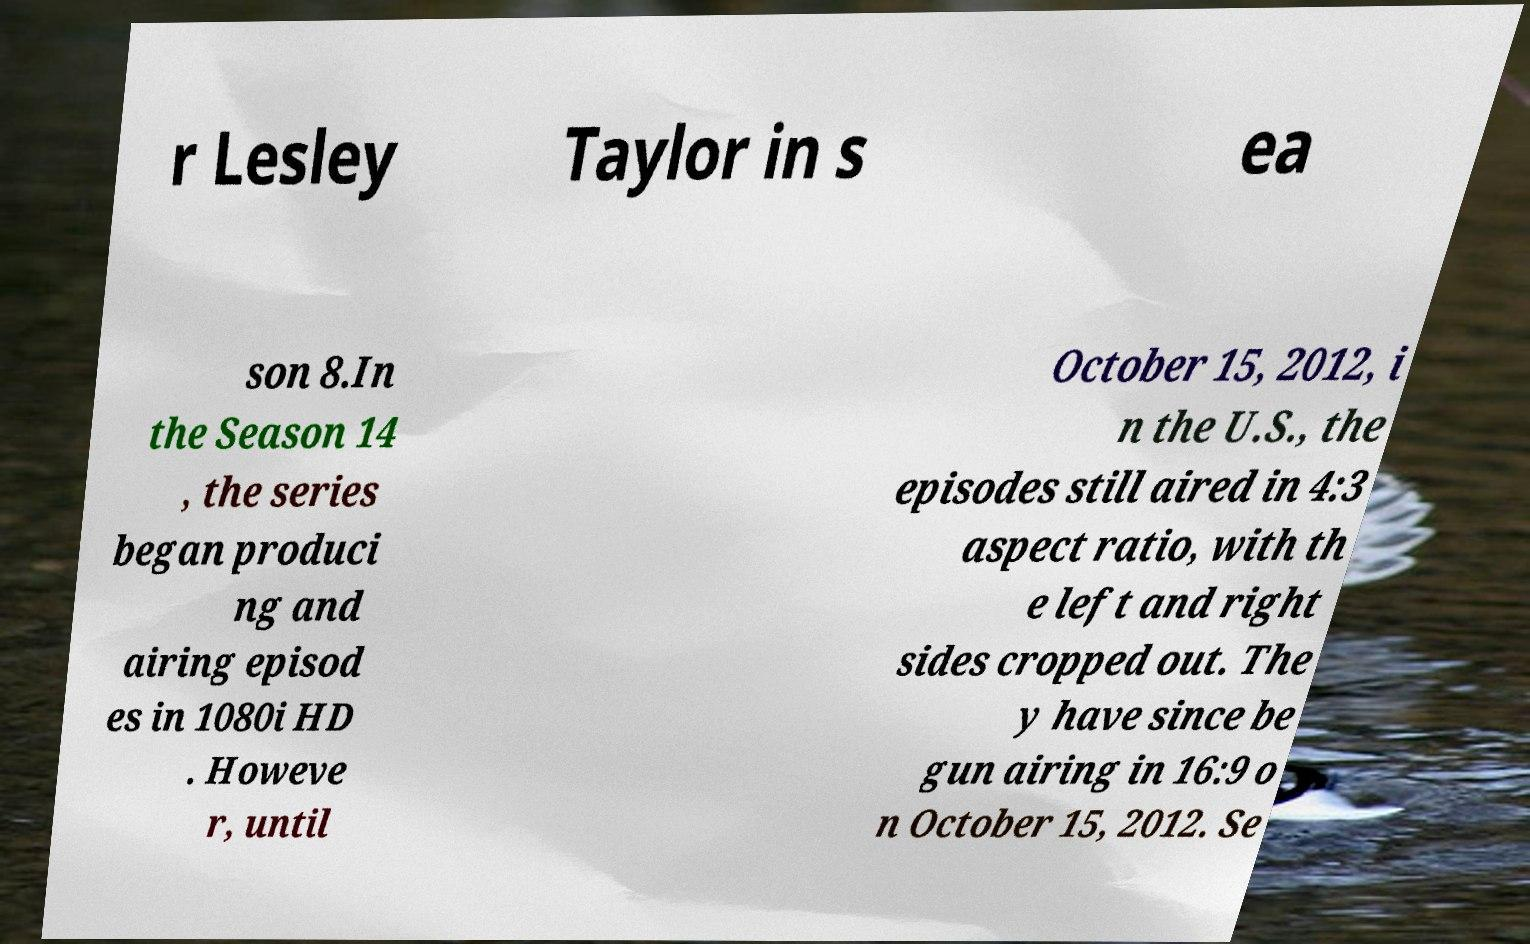For documentation purposes, I need the text within this image transcribed. Could you provide that? r Lesley Taylor in s ea son 8.In the Season 14 , the series began produci ng and airing episod es in 1080i HD . Howeve r, until October 15, 2012, i n the U.S., the episodes still aired in 4:3 aspect ratio, with th e left and right sides cropped out. The y have since be gun airing in 16:9 o n October 15, 2012. Se 